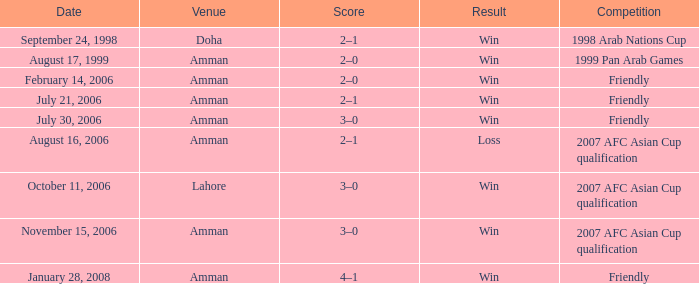What was the outcome of the friendly contest at amman on february 14, 2006? 2–0. 